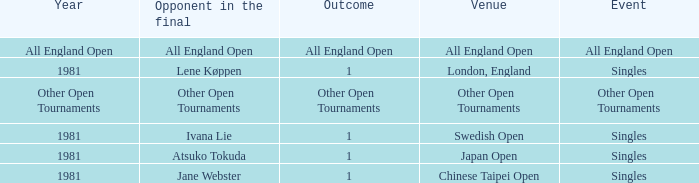What is the Outcome of the Singles Event in London, England? 1.0. 